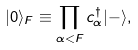Convert formula to latex. <formula><loc_0><loc_0><loc_500><loc_500>| 0 \rangle _ { F } \equiv \prod _ { \alpha < F } c _ { \alpha } ^ { \dagger } | - \rangle ,</formula> 